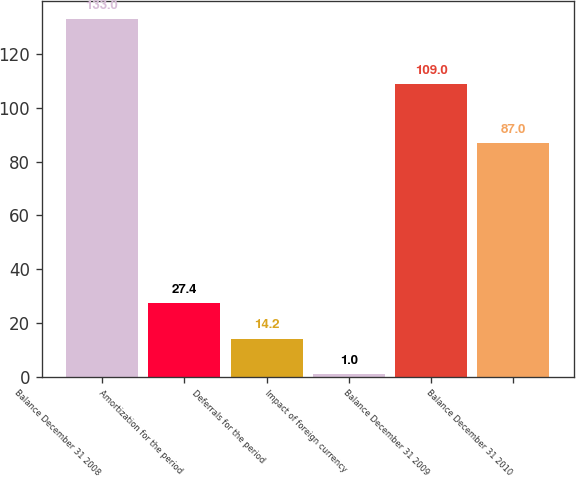Convert chart to OTSL. <chart><loc_0><loc_0><loc_500><loc_500><bar_chart><fcel>Balance December 31 2008<fcel>Amortization for the period<fcel>Deferrals for the period<fcel>Impact of foreign currency<fcel>Balance December 31 2009<fcel>Balance December 31 2010<nl><fcel>133<fcel>27.4<fcel>14.2<fcel>1<fcel>109<fcel>87<nl></chart> 